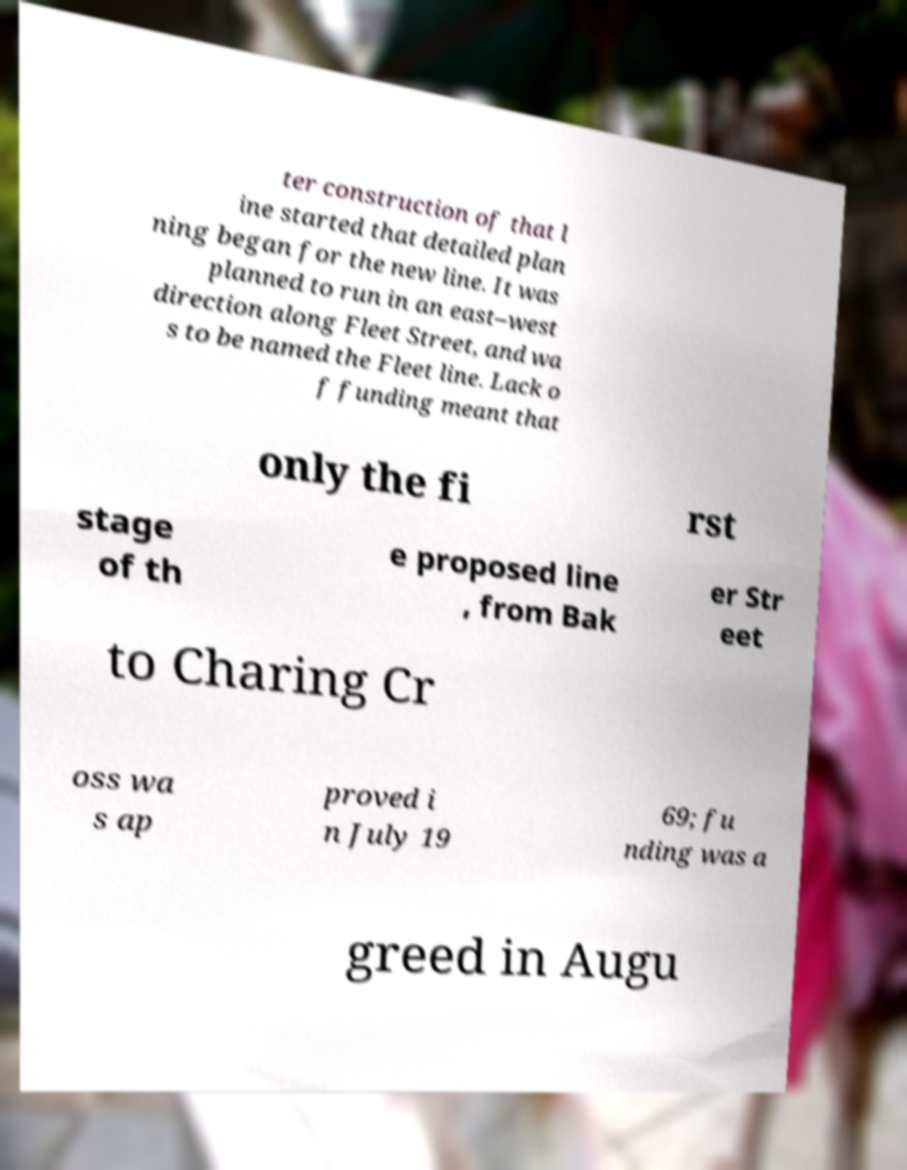What messages or text are displayed in this image? I need them in a readable, typed format. ter construction of that l ine started that detailed plan ning began for the new line. It was planned to run in an east–west direction along Fleet Street, and wa s to be named the Fleet line. Lack o f funding meant that only the fi rst stage of th e proposed line , from Bak er Str eet to Charing Cr oss wa s ap proved i n July 19 69; fu nding was a greed in Augu 